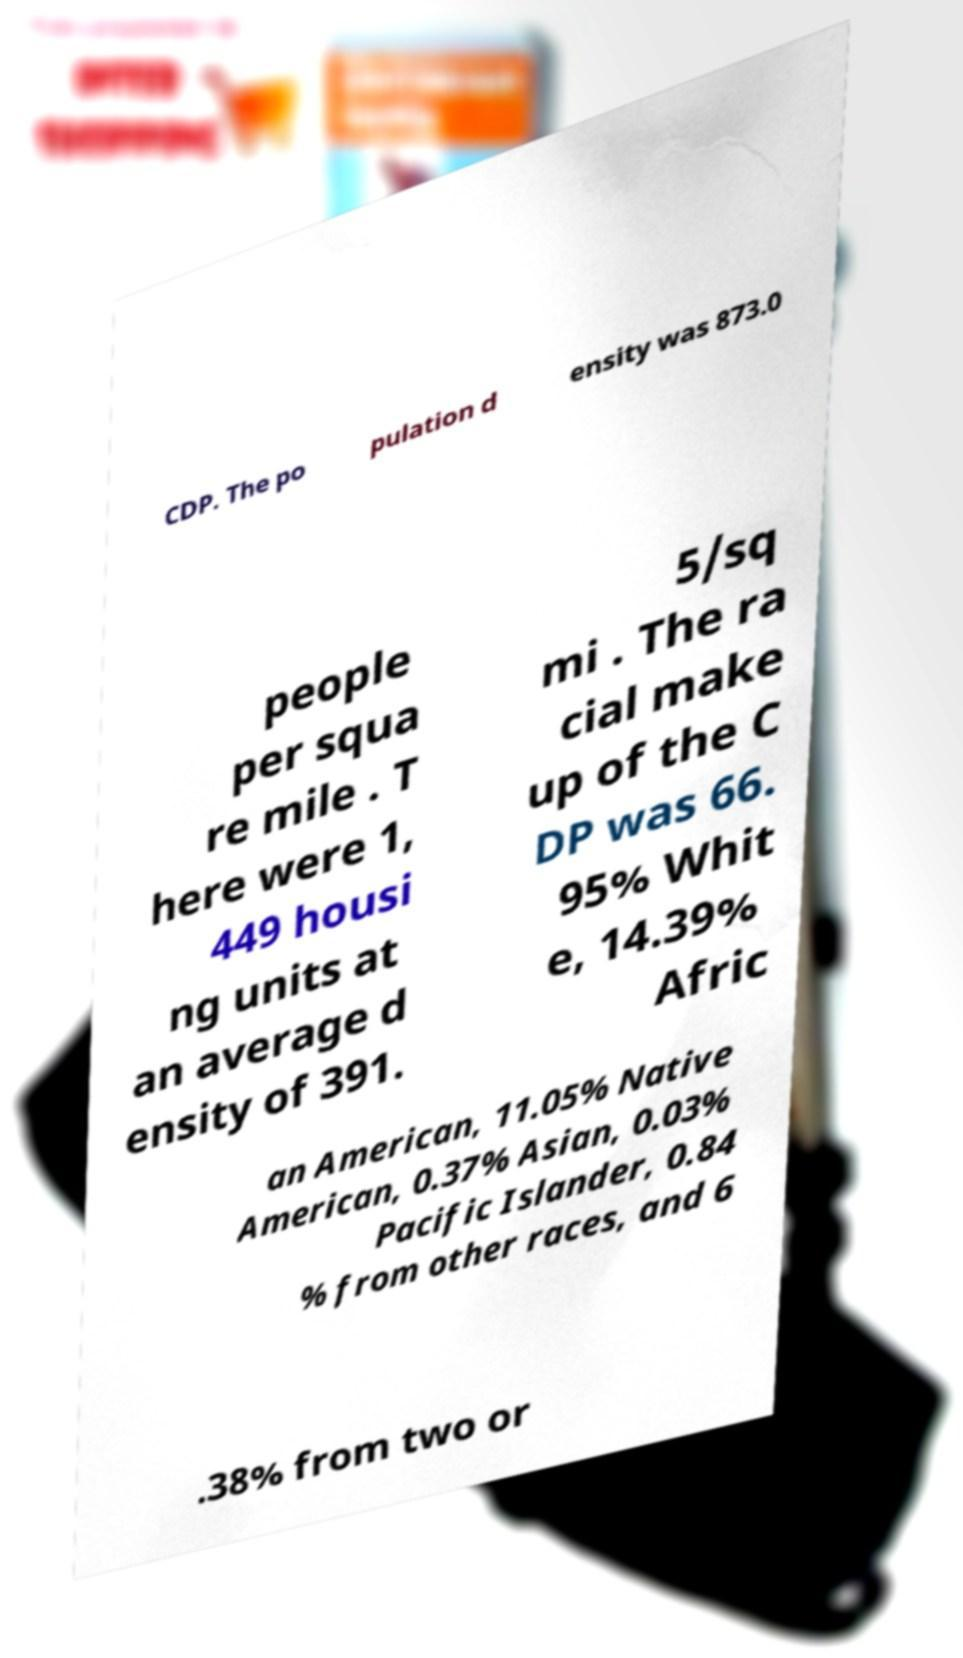Please identify and transcribe the text found in this image. CDP. The po pulation d ensity was 873.0 people per squa re mile . T here were 1, 449 housi ng units at an average d ensity of 391. 5/sq mi . The ra cial make up of the C DP was 66. 95% Whit e, 14.39% Afric an American, 11.05% Native American, 0.37% Asian, 0.03% Pacific Islander, 0.84 % from other races, and 6 .38% from two or 